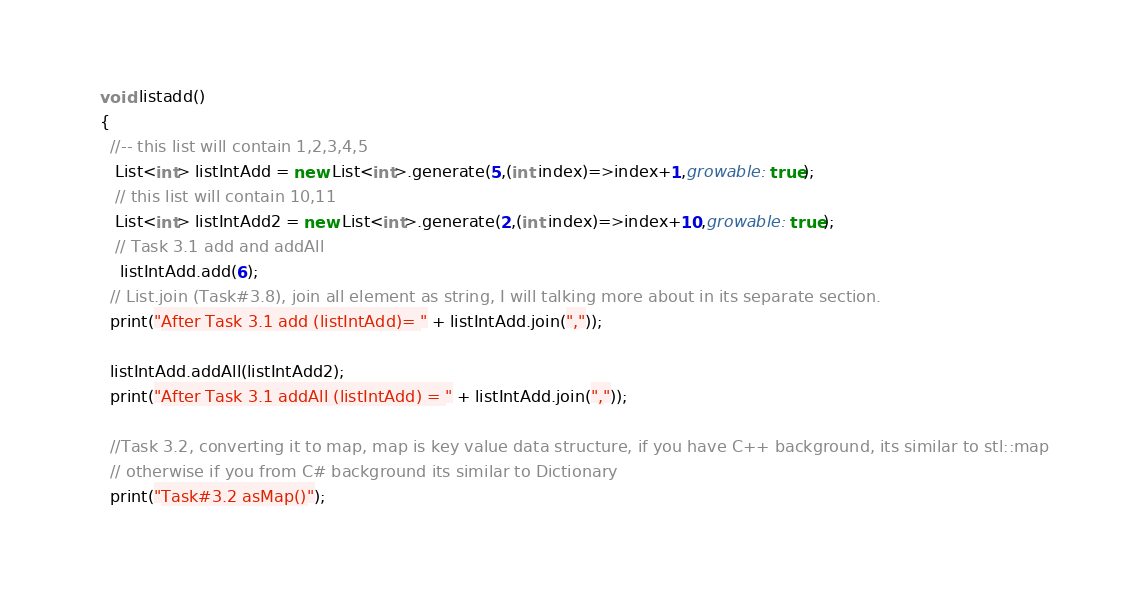Convert code to text. <code><loc_0><loc_0><loc_500><loc_500><_Dart_>void listadd()
{
  //-- this list will contain 1,2,3,4,5
   List<int> listIntAdd = new List<int>.generate(5,(int index)=>index+1,growable: true);
   // this list will contain 10,11
   List<int> listIntAdd2 = new List<int>.generate(2,(int index)=>index+10,growable: true);
   // Task 3.1 add and addAll
    listIntAdd.add(6);
  // List.join (Task#3.8), join all element as string, I will talking more about in its separate section.
  print("After Task 3.1 add (listIntAdd)= " + listIntAdd.join(","));

  listIntAdd.addAll(listIntAdd2);
  print("After Task 3.1 addAll (listIntAdd) = " + listIntAdd.join(","));

  //Task 3.2, converting it to map, map is key value data structure, if you have C++ background, its similar to stl::map
  // otherwise if you from C# background its similar to Dictionary
  print("Task#3.2 asMap()");</code> 